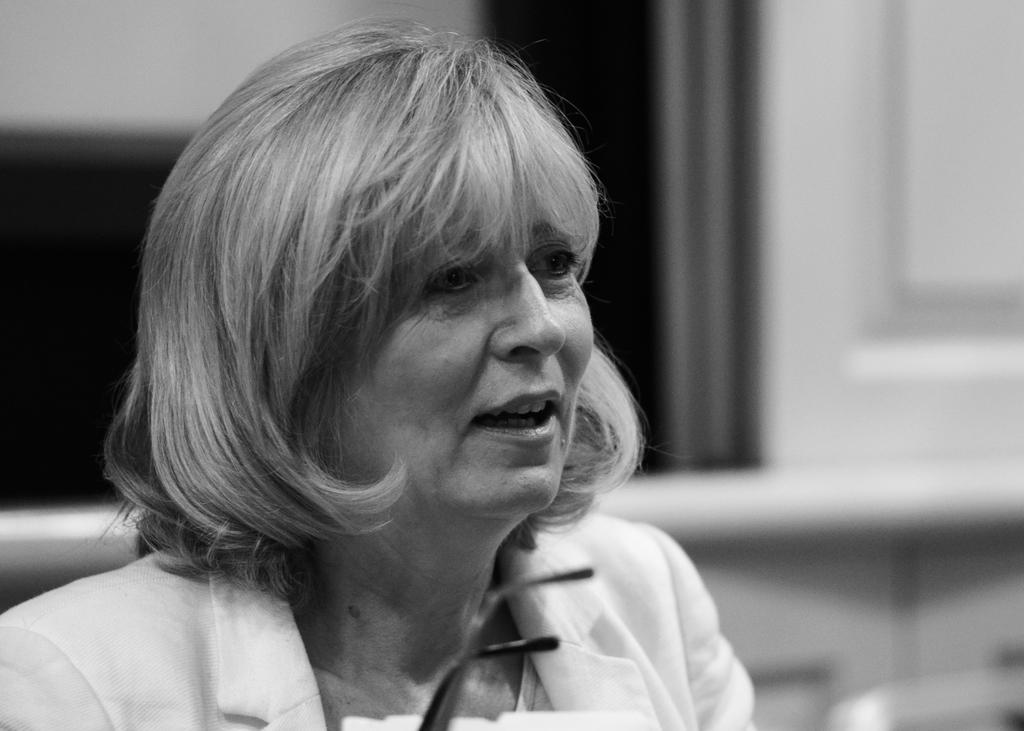What is the main subject of the image? There is a woman in the image. What is the color scheme of the image? The image is black and white. Can you describe the background of the image? The background of the image is blurred. What type of watch is the woman wearing in the image? There is no watch visible in the image. What type of police uniform is the woman wearing in the image? There is no police uniform visible in the image. What type of cover is the woman using to protect herself in the image? There is no cover visible in the image. 